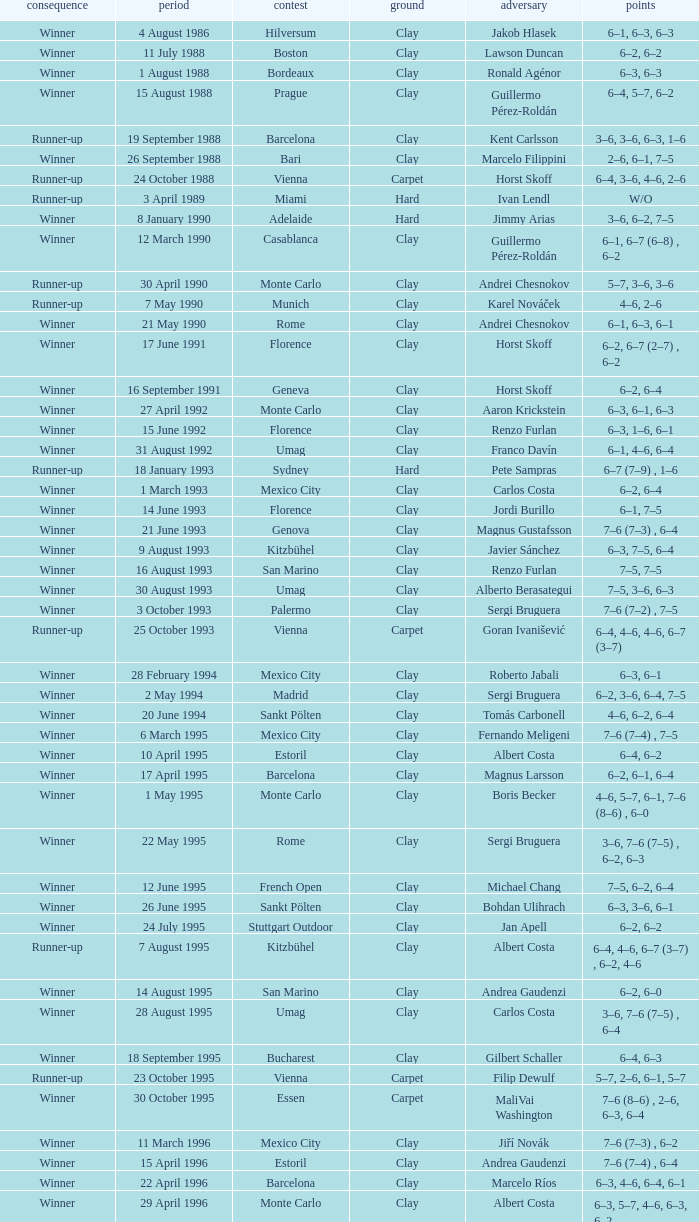What is the score when the outcome is winner against yevgeny kafelnikov? 6–2, 6–2, 6–4. 